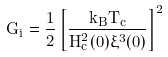Convert formula to latex. <formula><loc_0><loc_0><loc_500><loc_500>G _ { i } = \frac { 1 } { 2 } \left [ \frac { k _ { B } T _ { c } } { H _ { c } ^ { 2 } ( 0 ) \xi ^ { 3 } ( 0 ) } \right ] ^ { 2 }</formula> 